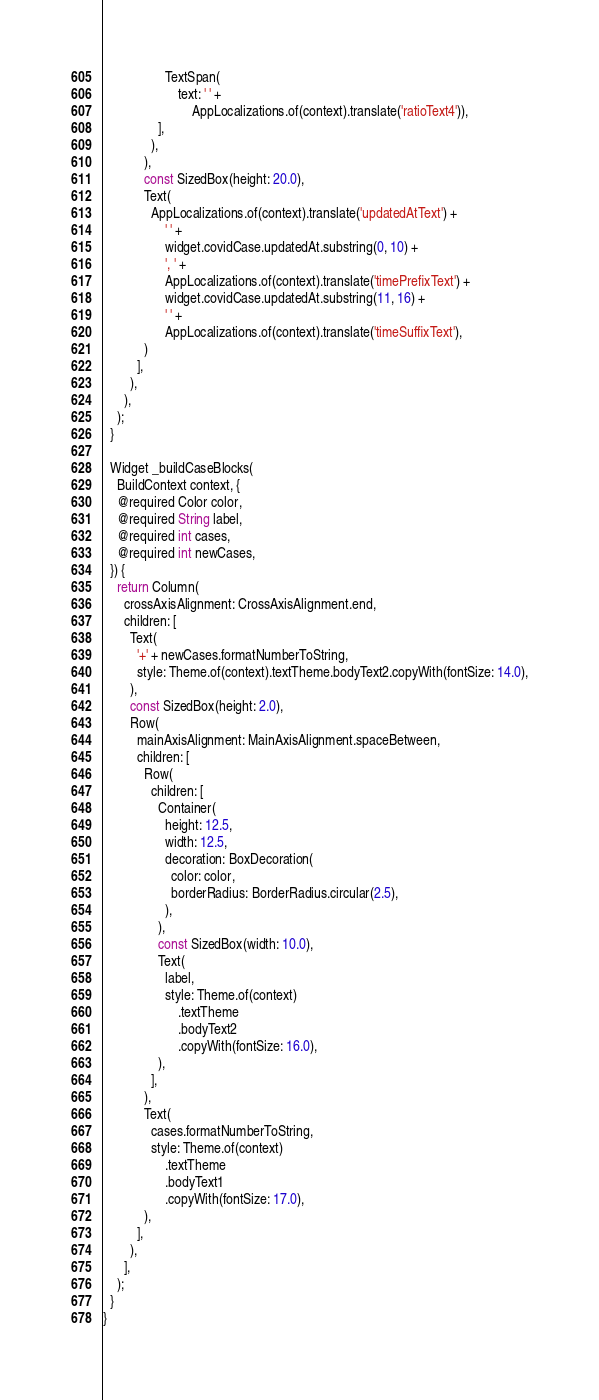Convert code to text. <code><loc_0><loc_0><loc_500><loc_500><_Dart_>                  TextSpan(
                      text: ' ' +
                          AppLocalizations.of(context).translate('ratioText4')),
                ],
              ),
            ),
            const SizedBox(height: 20.0),
            Text(
              AppLocalizations.of(context).translate('updatedAtText') +
                  ' ' +
                  widget.covidCase.updatedAt.substring(0, 10) +
                  ', ' +
                  AppLocalizations.of(context).translate('timePrefixText') +
                  widget.covidCase.updatedAt.substring(11, 16) +
                  ' ' +
                  AppLocalizations.of(context).translate('timeSuffixText'),
            )
          ],
        ),
      ),
    );
  }

  Widget _buildCaseBlocks(
    BuildContext context, {
    @required Color color,
    @required String label,
    @required int cases,
    @required int newCases,
  }) {
    return Column(
      crossAxisAlignment: CrossAxisAlignment.end,
      children: [
        Text(
          '+' + newCases.formatNumberToString,
          style: Theme.of(context).textTheme.bodyText2.copyWith(fontSize: 14.0),
        ),
        const SizedBox(height: 2.0),
        Row(
          mainAxisAlignment: MainAxisAlignment.spaceBetween,
          children: [
            Row(
              children: [
                Container(
                  height: 12.5,
                  width: 12.5,
                  decoration: BoxDecoration(
                    color: color,
                    borderRadius: BorderRadius.circular(2.5),
                  ),
                ),
                const SizedBox(width: 10.0),
                Text(
                  label,
                  style: Theme.of(context)
                      .textTheme
                      .bodyText2
                      .copyWith(fontSize: 16.0),
                ),
              ],
            ),
            Text(
              cases.formatNumberToString,
              style: Theme.of(context)
                  .textTheme
                  .bodyText1
                  .copyWith(fontSize: 17.0),
            ),
          ],
        ),
      ],
    );
  }
}
</code> 